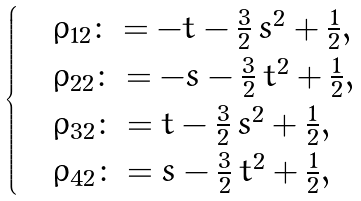<formula> <loc_0><loc_0><loc_500><loc_500>\begin{cases} & \rho _ { 1 2 } \colon = - t - \frac { 3 } { 2 } \, s ^ { 2 } + \frac { 1 } { 2 } , \\ & \rho _ { 2 2 } \colon = - s - \frac { 3 } { 2 } \, t ^ { 2 } + \frac { 1 } { 2 } , \quad \, \quad \\ & \rho _ { 3 2 } \colon = t - \frac { 3 } { 2 } \, s ^ { 2 } + \frac { 1 } { 2 } , \\ & \rho _ { 4 2 } \colon = s - \frac { 3 } { 2 } \, t ^ { 2 } + \frac { 1 } { 2 } , \end{cases}</formula> 